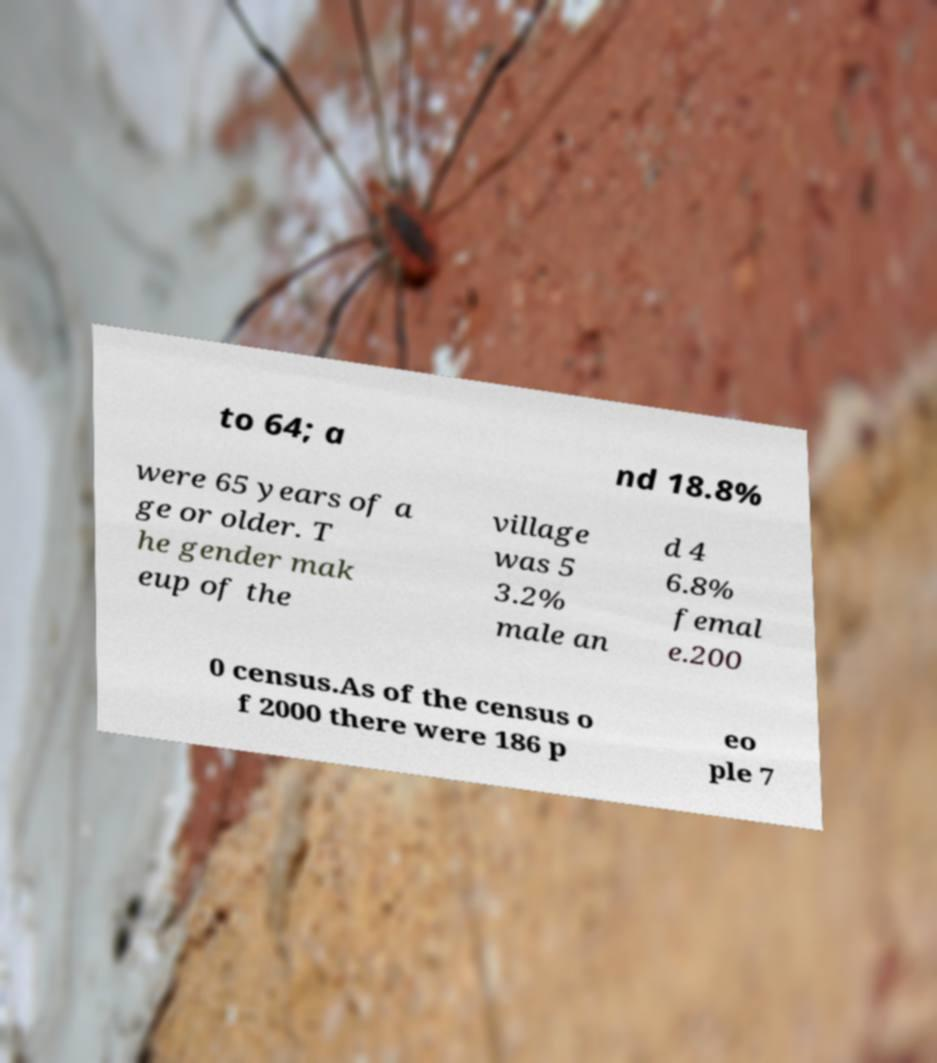Can you accurately transcribe the text from the provided image for me? to 64; a nd 18.8% were 65 years of a ge or older. T he gender mak eup of the village was 5 3.2% male an d 4 6.8% femal e.200 0 census.As of the census o f 2000 there were 186 p eo ple 7 